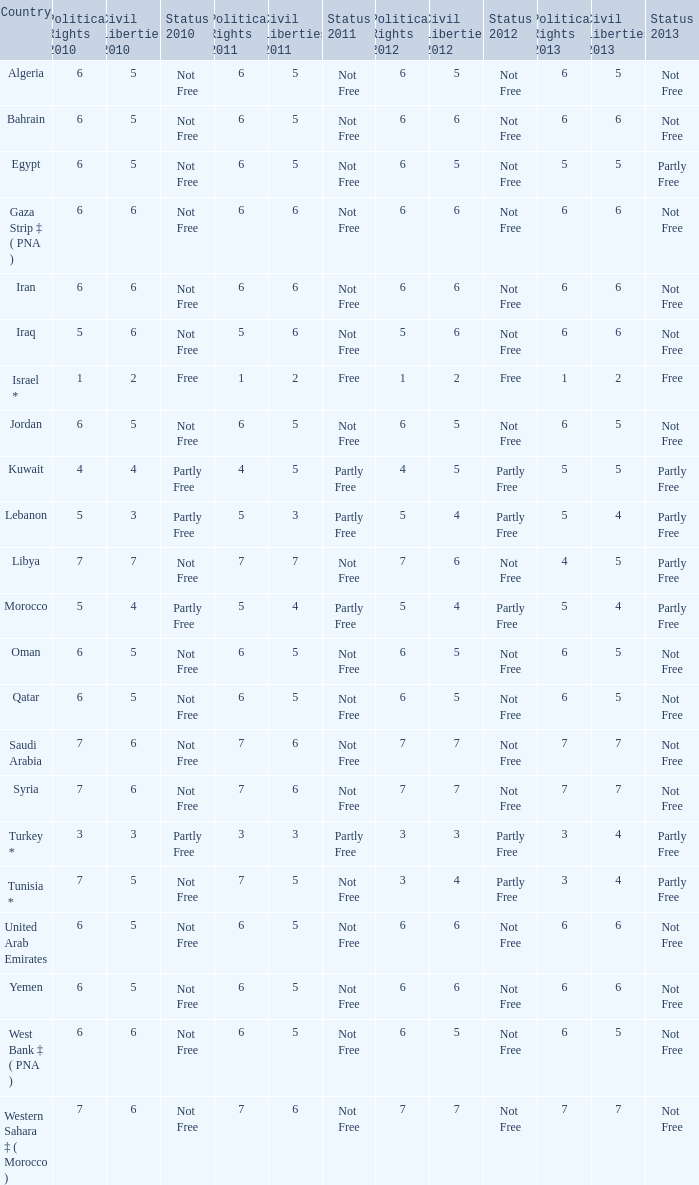What is the median 2012 civil liberties value related to a 2011 situation of not free, political rights 2012 above 6, and political rights 2011 beyond 7 None. 